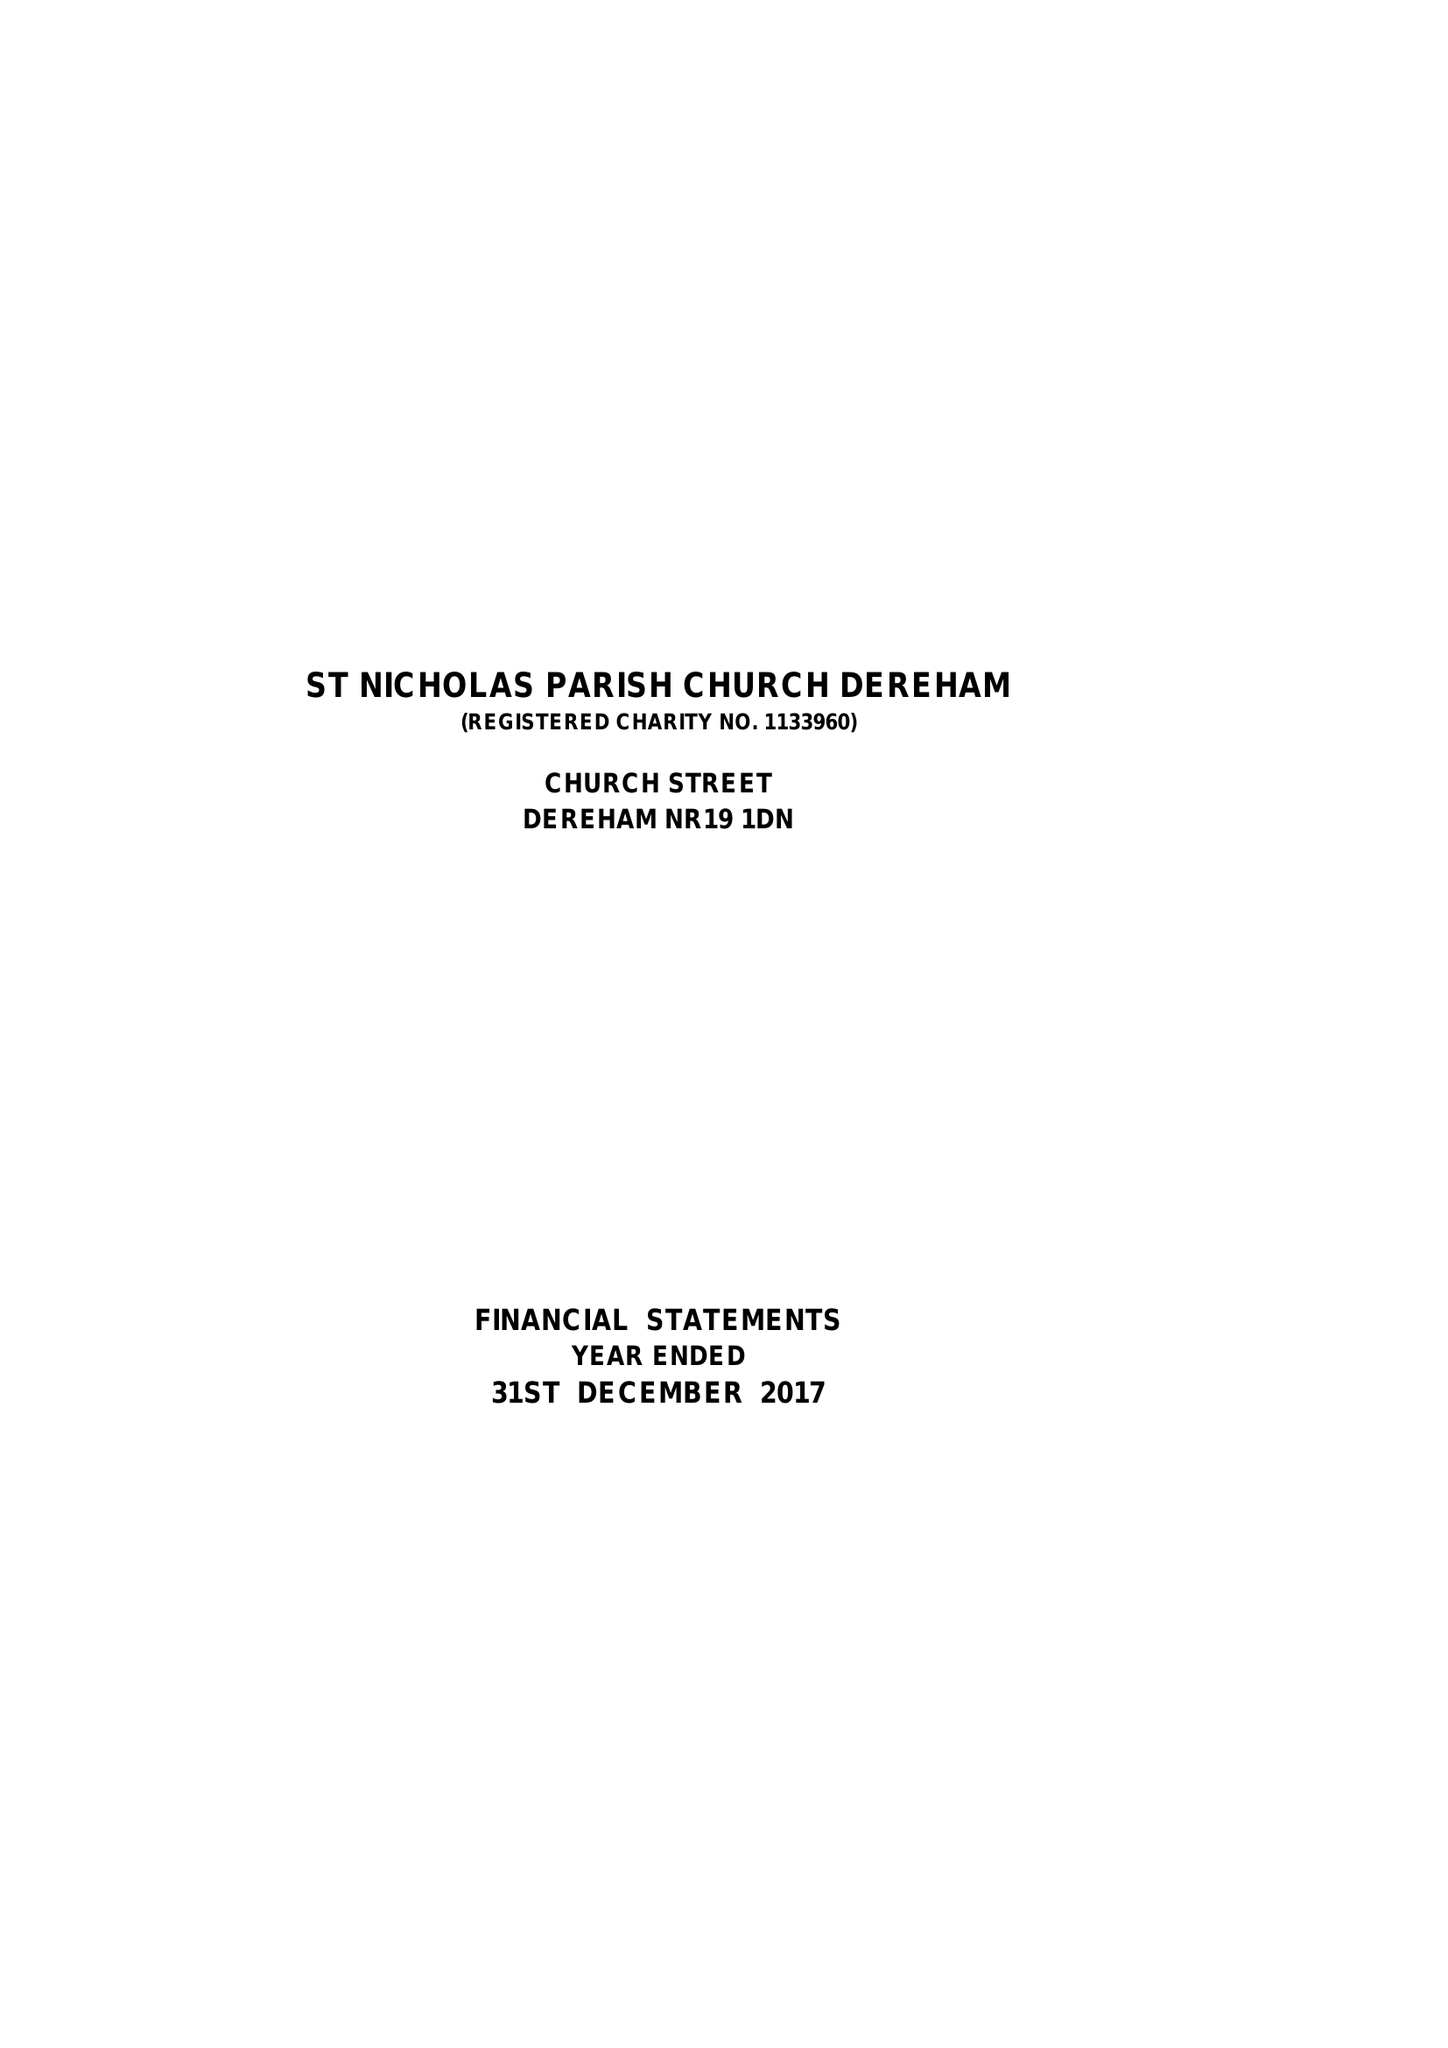What is the value for the charity_name?
Answer the question using a single word or phrase. The Parochial Church Council Of The Ecclesiastical Parish Of St Nicholas, Dereham 